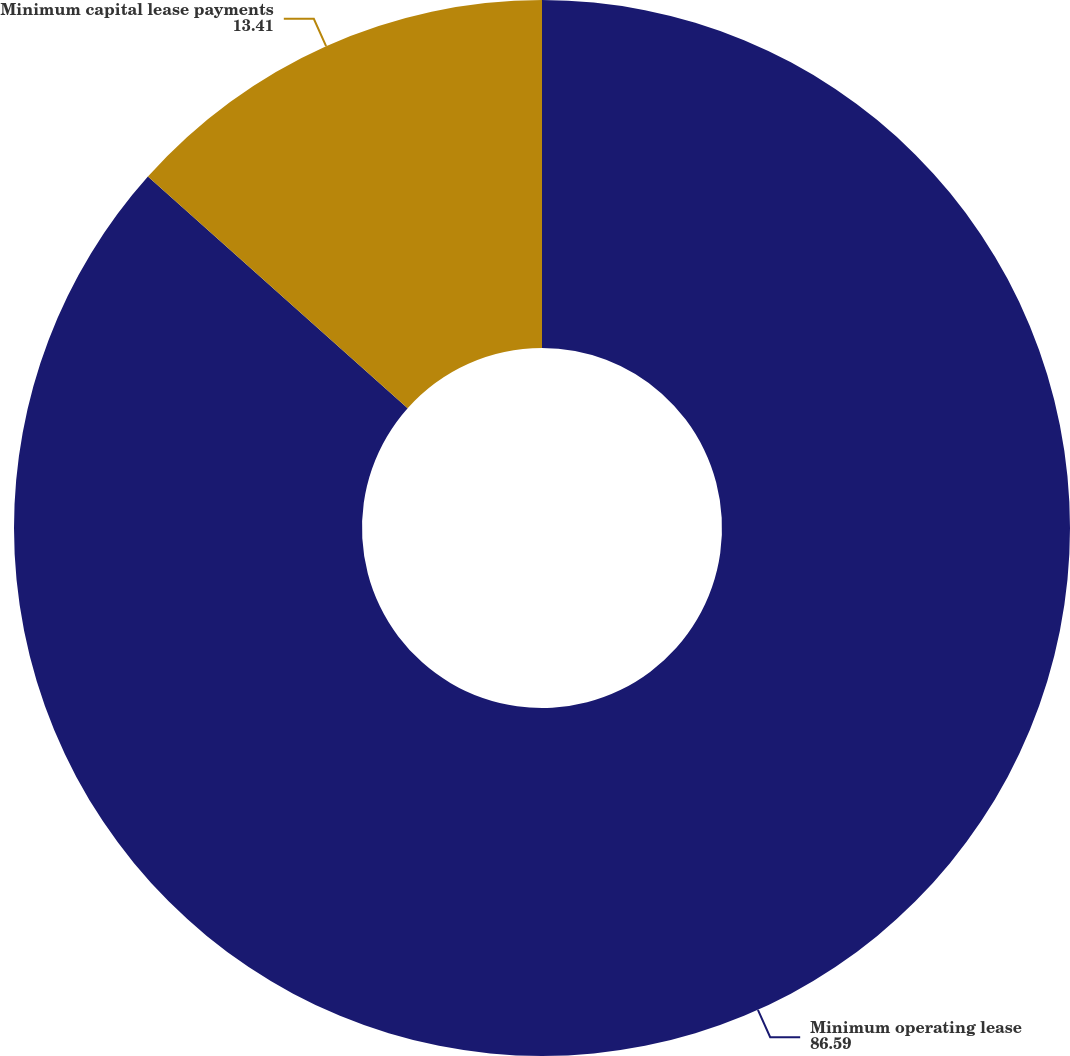Convert chart. <chart><loc_0><loc_0><loc_500><loc_500><pie_chart><fcel>Minimum operating lease<fcel>Minimum capital lease payments<nl><fcel>86.59%<fcel>13.41%<nl></chart> 